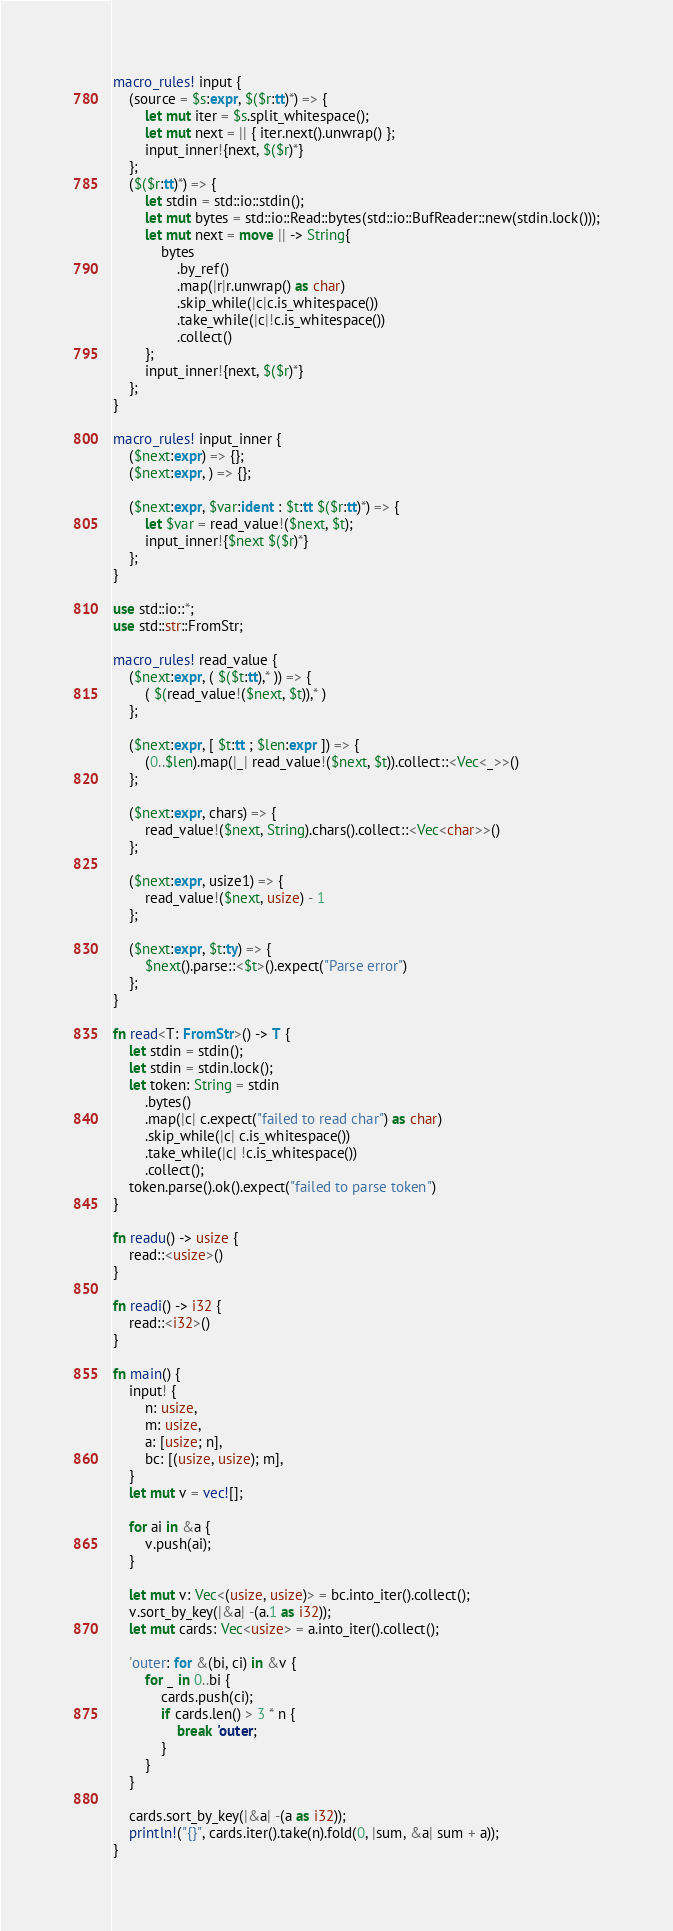Convert code to text. <code><loc_0><loc_0><loc_500><loc_500><_Rust_>macro_rules! input {
    (source = $s:expr, $($r:tt)*) => {
        let mut iter = $s.split_whitespace();
        let mut next = || { iter.next().unwrap() };
        input_inner!{next, $($r)*}
    };
    ($($r:tt)*) => {
        let stdin = std::io::stdin();
        let mut bytes = std::io::Read::bytes(std::io::BufReader::new(stdin.lock()));
        let mut next = move || -> String{
            bytes
                .by_ref()
                .map(|r|r.unwrap() as char)
                .skip_while(|c|c.is_whitespace())
                .take_while(|c|!c.is_whitespace())
                .collect()
        };
        input_inner!{next, $($r)*}
    };
}

macro_rules! input_inner {
    ($next:expr) => {};
    ($next:expr, ) => {};

    ($next:expr, $var:ident : $t:tt $($r:tt)*) => {
        let $var = read_value!($next, $t);
        input_inner!{$next $($r)*}
    };
}

use std::io::*;
use std::str::FromStr;

macro_rules! read_value {
    ($next:expr, ( $($t:tt),* )) => {
        ( $(read_value!($next, $t)),* )
    };

    ($next:expr, [ $t:tt ; $len:expr ]) => {
        (0..$len).map(|_| read_value!($next, $t)).collect::<Vec<_>>()
    };

    ($next:expr, chars) => {
        read_value!($next, String).chars().collect::<Vec<char>>()
    };

    ($next:expr, usize1) => {
        read_value!($next, usize) - 1
    };

    ($next:expr, $t:ty) => {
        $next().parse::<$t>().expect("Parse error")
    };
}

fn read<T: FromStr>() -> T {
    let stdin = stdin();
    let stdin = stdin.lock();
    let token: String = stdin
        .bytes()
        .map(|c| c.expect("failed to read char") as char)
        .skip_while(|c| c.is_whitespace())
        .take_while(|c| !c.is_whitespace())
        .collect();
    token.parse().ok().expect("failed to parse token")
}

fn readu() -> usize {
    read::<usize>()
}

fn readi() -> i32 {
    read::<i32>()
}

fn main() {
    input! {
        n: usize,
        m: usize,
        a: [usize; n],
        bc: [(usize, usize); m],
    }
    let mut v = vec![];

    for ai in &a {
        v.push(ai);
    }

    let mut v: Vec<(usize, usize)> = bc.into_iter().collect();
    v.sort_by_key(|&a| -(a.1 as i32));
    let mut cards: Vec<usize> = a.into_iter().collect();

    'outer: for &(bi, ci) in &v {
        for _ in 0..bi {
            cards.push(ci);
            if cards.len() > 3 * n {
                break 'outer;
            }
        }
    }

    cards.sort_by_key(|&a| -(a as i32));
    println!("{}", cards.iter().take(n).fold(0, |sum, &a| sum + a));
}</code> 